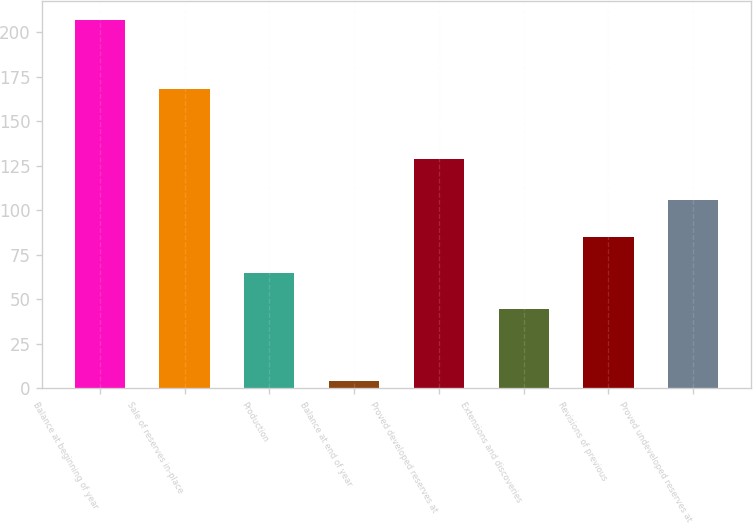Convert chart to OTSL. <chart><loc_0><loc_0><loc_500><loc_500><bar_chart><fcel>Balance at beginning of year<fcel>Sale of reserves in-place<fcel>Production<fcel>Balance at end of year<fcel>Proved developed reserves at<fcel>Extensions and discoveries<fcel>Revisions of previous<fcel>Proved undeveloped reserves at<nl><fcel>207<fcel>168<fcel>64.9<fcel>4<fcel>129<fcel>44.6<fcel>85.2<fcel>105.5<nl></chart> 